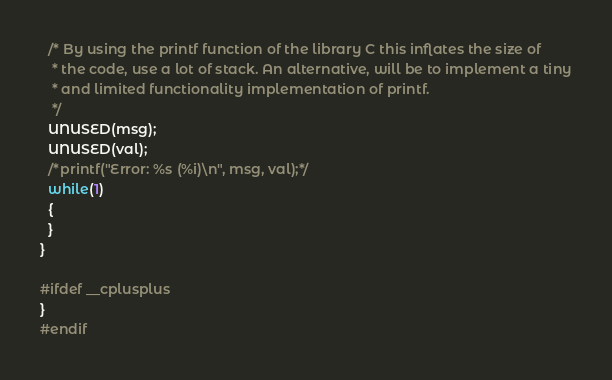<code> <loc_0><loc_0><loc_500><loc_500><_C_>  /* By using the printf function of the library C this inflates the size of
   * the code, use a lot of stack. An alternative, will be to implement a tiny
   * and limited functionality implementation of printf.
   */
  UNUSED(msg);
  UNUSED(val);
  /*printf("Error: %s (%i)\n", msg, val);*/
  while(1)
  {
  }
}

#ifdef __cplusplus
}
#endif
</code> 